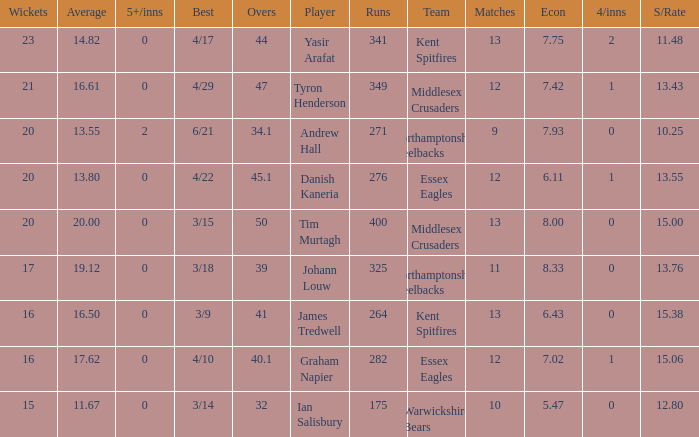Name the least matches for runs being 276 12.0. 